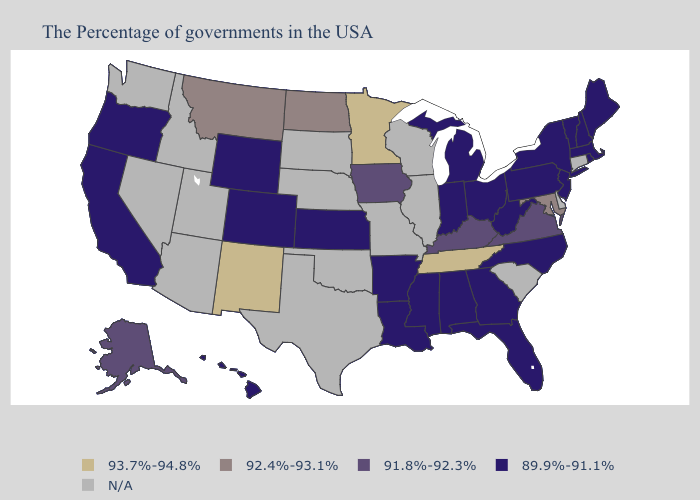What is the highest value in the West ?
Write a very short answer. 93.7%-94.8%. What is the highest value in the Northeast ?
Give a very brief answer. 89.9%-91.1%. Does New Jersey have the highest value in the USA?
Write a very short answer. No. Name the states that have a value in the range 91.8%-92.3%?
Concise answer only. Virginia, Kentucky, Iowa, Alaska. Name the states that have a value in the range 93.7%-94.8%?
Write a very short answer. Tennessee, Minnesota, New Mexico. Name the states that have a value in the range 92.4%-93.1%?
Keep it brief. Maryland, North Dakota, Montana. Name the states that have a value in the range 93.7%-94.8%?
Quick response, please. Tennessee, Minnesota, New Mexico. What is the value of Florida?
Short answer required. 89.9%-91.1%. What is the lowest value in the USA?
Answer briefly. 89.9%-91.1%. Name the states that have a value in the range 91.8%-92.3%?
Quick response, please. Virginia, Kentucky, Iowa, Alaska. What is the highest value in the USA?
Keep it brief. 93.7%-94.8%. What is the lowest value in states that border California?
Answer briefly. 89.9%-91.1%. Which states hav the highest value in the Northeast?
Quick response, please. Maine, Massachusetts, Rhode Island, New Hampshire, Vermont, New York, New Jersey, Pennsylvania. How many symbols are there in the legend?
Answer briefly. 5. 